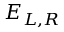Convert formula to latex. <formula><loc_0><loc_0><loc_500><loc_500>E _ { L , R }</formula> 